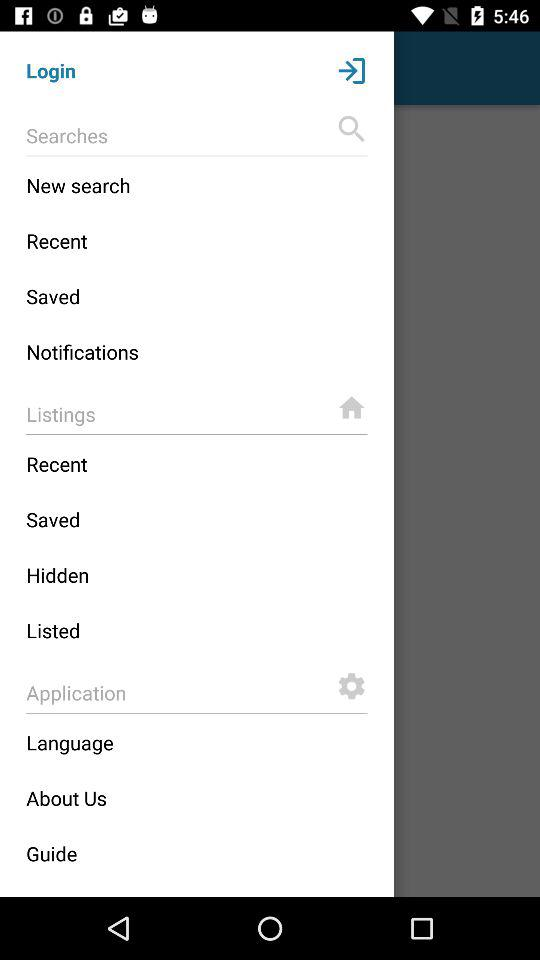In which category is the "Language" option present? The "Language" option is present in the "Application" category. 